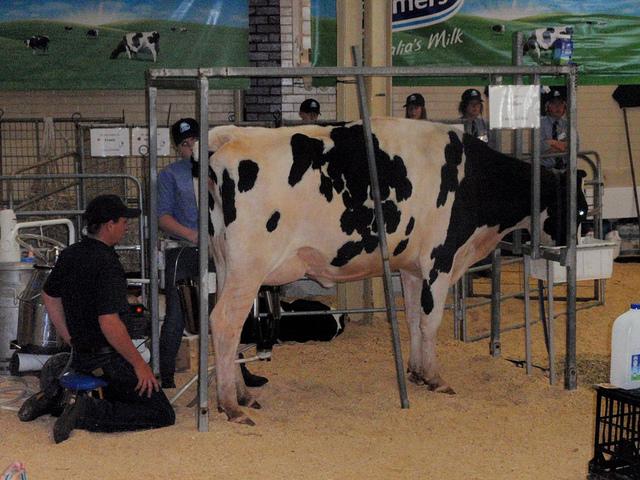How many cows are standing up?
Keep it brief. 1. What are the cows eating?
Give a very brief answer. Hay. Are there trees in the background?
Quick response, please. No. Is the man holding something in his right hand?
Write a very short answer. No. Are the cows currently being milked?
Keep it brief. Yes. Are these goats?
Quick response, please. No. How many cows are in the picture?
Concise answer only. 1. What are they doing to the cow?
Write a very short answer. Milking. What color is the barrel behind the fence?
Be succinct. Silver. What number is on the cow?
Keep it brief. 0. What is in background of cow?
Short answer required. People. What are the animals eating?
Write a very short answer. Water. Does the cow eat enough?
Concise answer only. Yes. Why does she have a cow on her shirt?
Keep it brief. Uniform. Is this likely a foreign country?
Answer briefly. No. Is the cow free to move about?
Quick response, please. No. What color is the cow?
Short answer required. Black and white. Is someone wearing sandals?
Keep it brief. No. How many spots are on the cows?
Short answer required. 16. Does the cow look out of place?
Write a very short answer. No. Has the cow been milked today?
Give a very brief answer. Yes. 